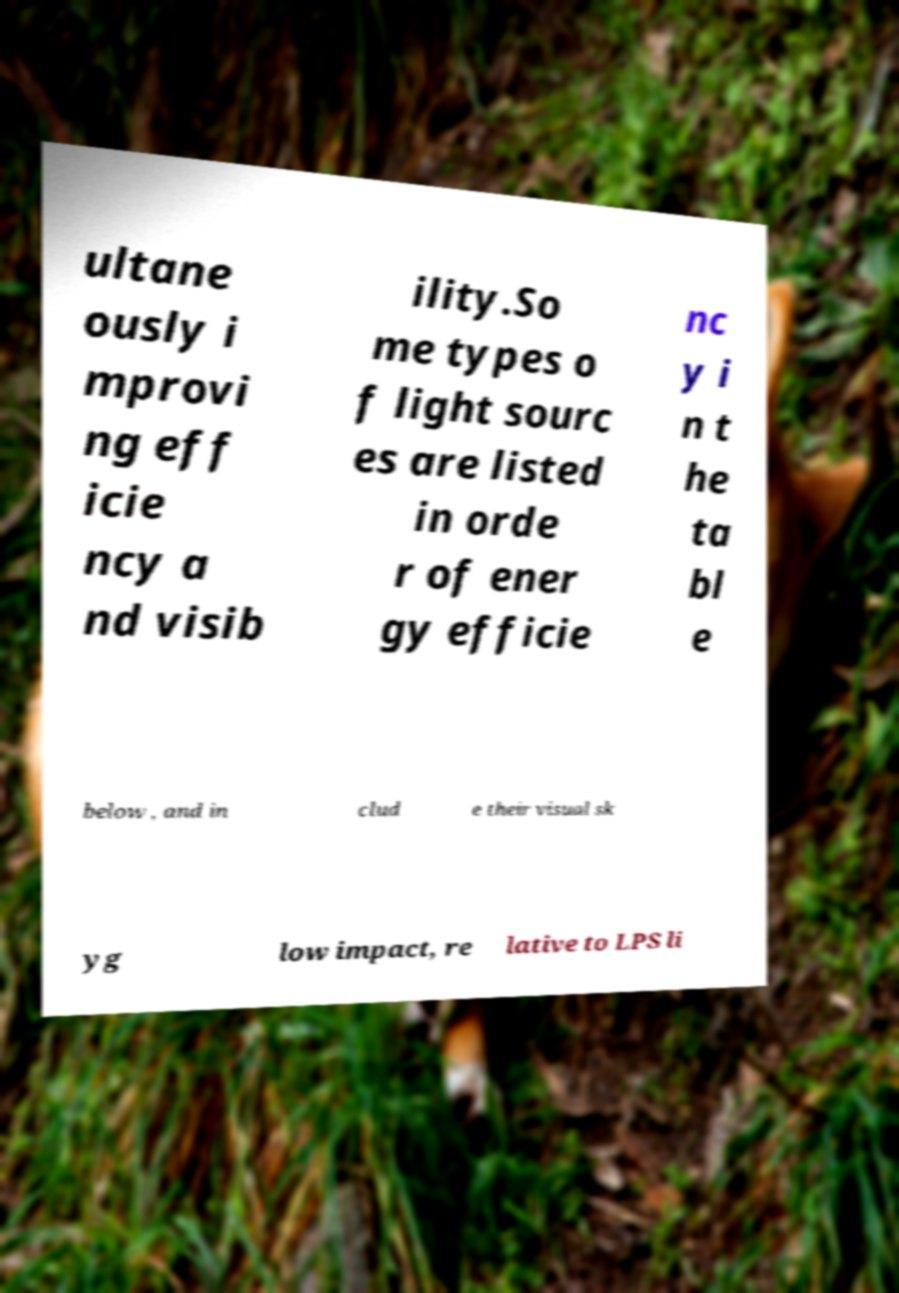There's text embedded in this image that I need extracted. Can you transcribe it verbatim? ultane ously i mprovi ng eff icie ncy a nd visib ility.So me types o f light sourc es are listed in orde r of ener gy efficie nc y i n t he ta bl e below , and in clud e their visual sk yg low impact, re lative to LPS li 